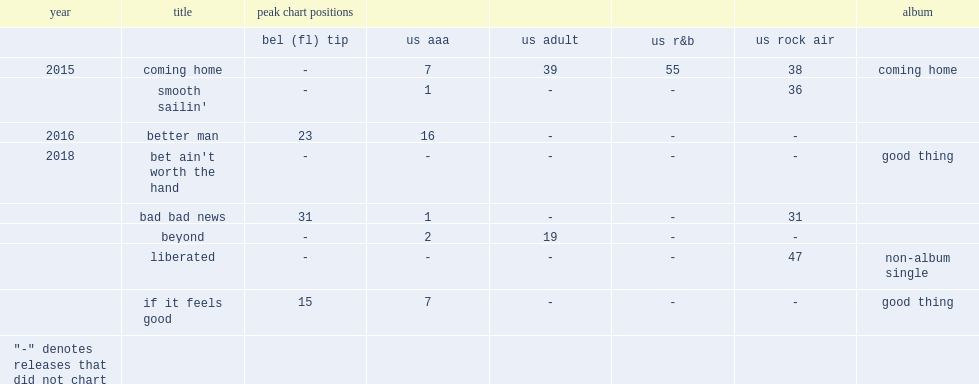Which year did "beyond" release? 2018.0. 